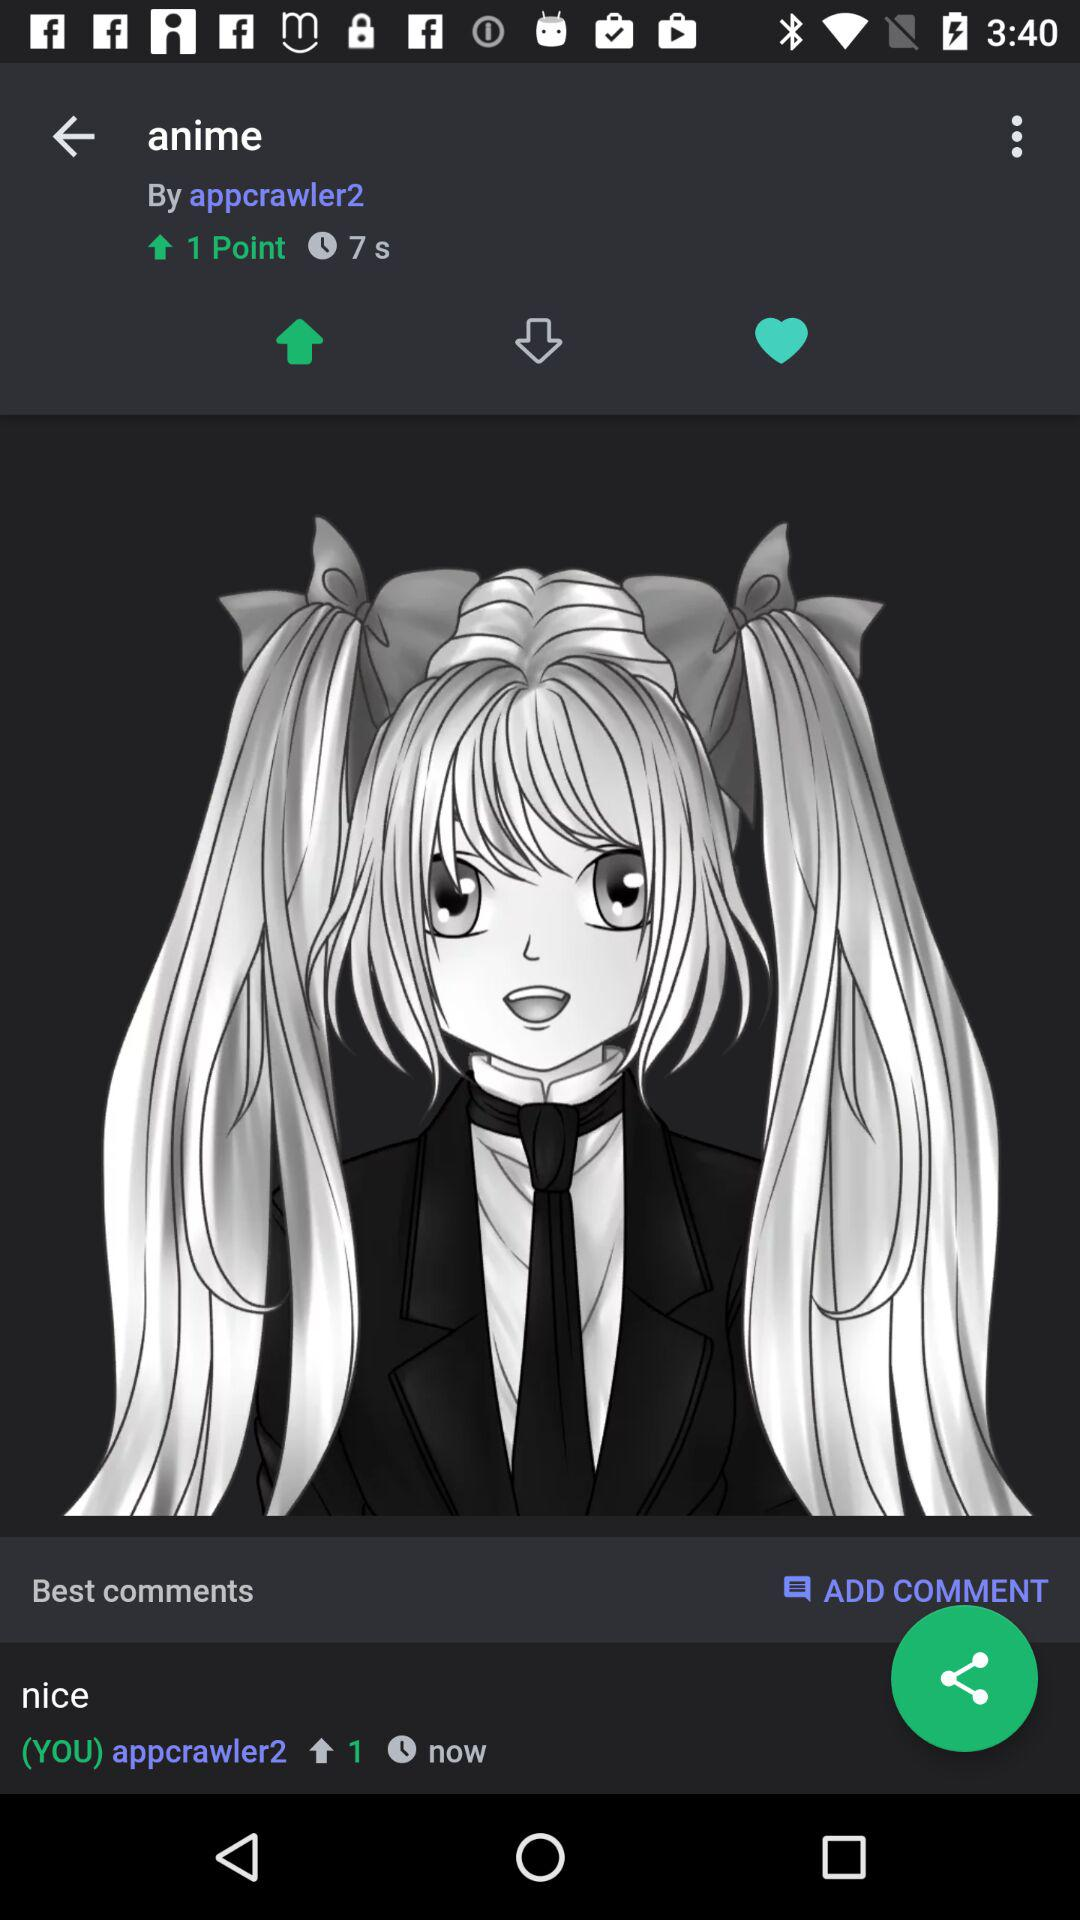How long ago was the comment posted? The comment is posted now. 